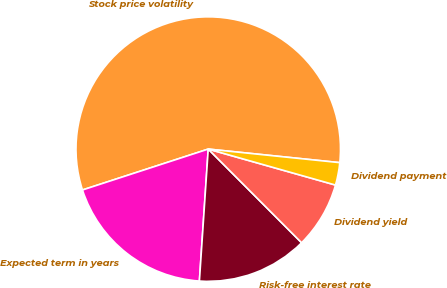<chart> <loc_0><loc_0><loc_500><loc_500><pie_chart><fcel>Stock price volatility<fcel>Expected term in years<fcel>Risk-free interest rate<fcel>Dividend yield<fcel>Dividend payment<nl><fcel>56.64%<fcel>18.93%<fcel>13.54%<fcel>8.14%<fcel>2.75%<nl></chart> 